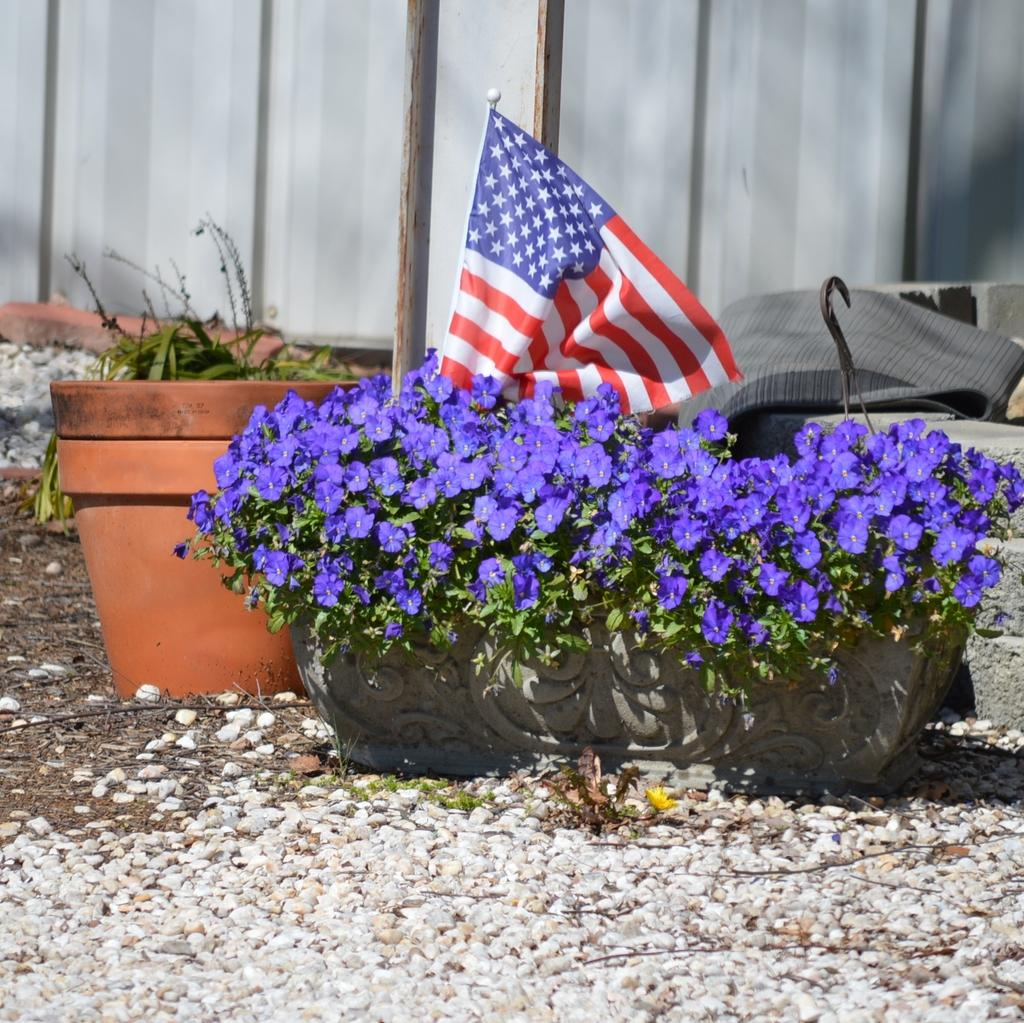What type of objects are present in the image that contain plants? There are pots with plants in the image. What decorative elements can be seen on the pots? The pots have flowers on them. Is there any other notable feature on one of the pots? Yes, there is a flag on one of the pots. What can be observed on the ground in the image? There are stones on the ground. What is visible in the background of the image? There is a wall in the background of the image. How many potatoes are visible in the image? There are no potatoes present in the image. What type of body is depicted in the image? There is no body depicted in the image; it features pots with plants, flowers, and a flag. 